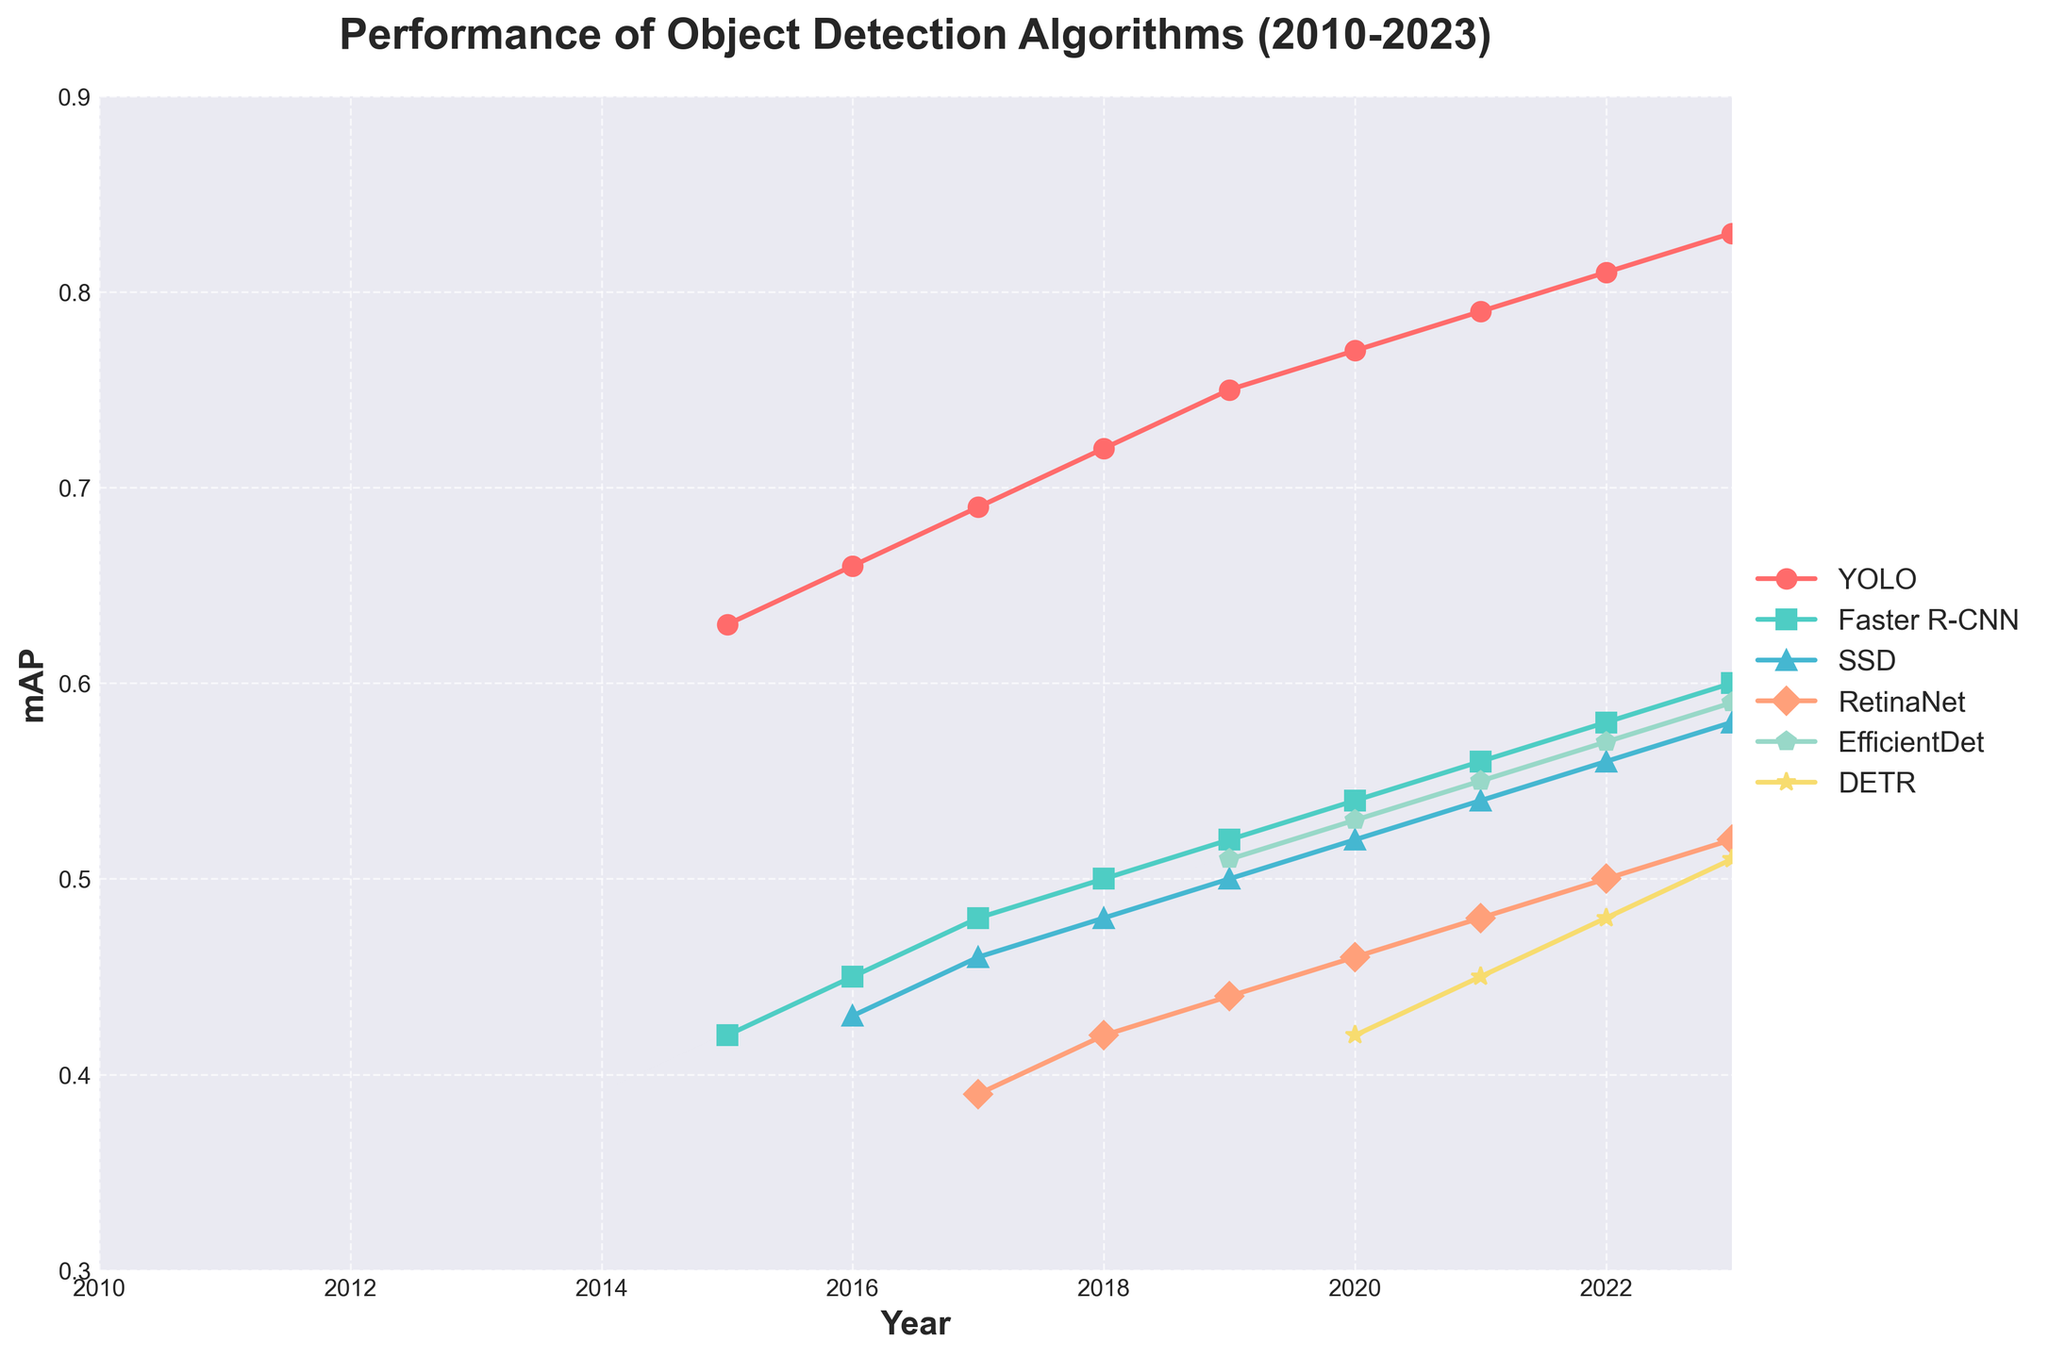Which algorithm showed the most significant increase in mAP from 2015 to 2023? By examining the figure, we can see that YOLO's mAP increased from 0.63 in 2015 to 0.83 in 2023. This is the largest increase among all algorithms.
Answer: YOLO Which algorithm had the highest mAP in 2021? By looking at the 2021 data points, YOLO had the highest mAP with a value of 0.79.
Answer: YOLO Did any algorithm have a higher mAP than 0.6 in 2016? Checking the 2016 data points, no algorithm has an mAP higher than 0.6.
Answer: No Comparing the trends, which algorithm showed a steady increase without any dips or fluctuations? YOLO showed a steady increase in mAP from 2015 to 2023 without any noticeable dips or fluctuations.
Answer: YOLO Which algorithm's mAP was closest to EfficientDet's mAP in 2020? In 2020, EfficientDet's mAP was 0.53. Comparing it to other algorithms, SSD had a similar mAP of 0.52, which is closest.
Answer: SSD What was the average mAP of RetinaNet from 2017 to 2023? RetinaNet has mAPs of 0.39 (2017), 0.42 (2018), 0.44 (2019), 0.46 (2020), 0.48 (2021), 0.50 (2022), and 0.52 (2023). Summing these values gives 0.39 + 0.42 + 0.44 + 0.46 + 0.48 + 0.50 + 0.52 = 3.21. Dividing by 7 years, the average is 3.21 / 7 ≈ 0.46.
Answer: 0.46 How did the performance of Faster R-CNN change from 2015 to 2016 compared to the change from 2022 to 2023? From 2015 to 2016, Faster R-CNN's mAP increased from 0.42 to 0.45, a change of +0.03. From 2022 to 2023, it increased from 0.58 to 0.60, a change of +0.02. The change from 2015 to 2016 is greater.
Answer: 2015 to 2016 Among YOLO, Faster R-CNN, and SSD, which algorithm had the lowest mAP in 2017? By looking at the 2017 data points, Faster R-CNN had a mAP of 0.48, SSD had 0.46, and YOLO had 0.69. Therefore, SSD had the lowest mAP.
Answer: SSD 